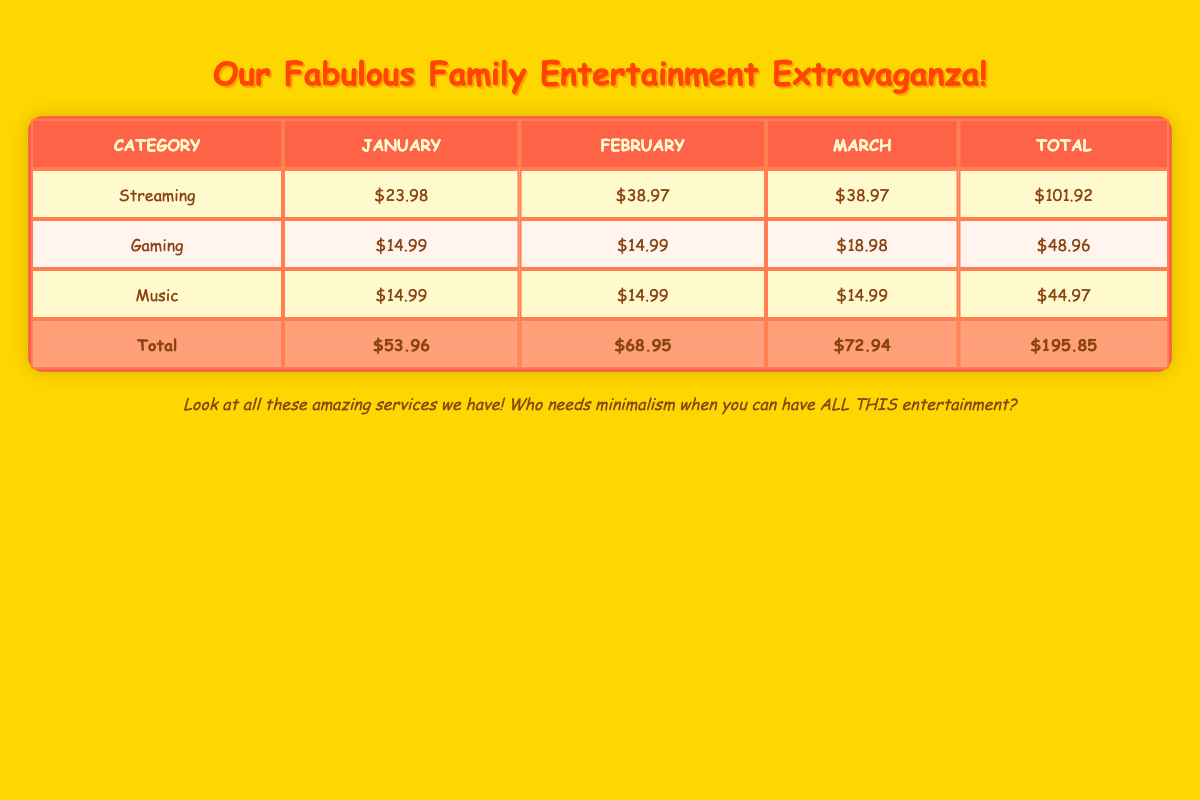What is the total cost for streaming services in January? You can find the row for "Streaming" under the January column. The total is the sum of Netflix ($15.99) and Disney+ ($7.99), which equals $15.99 + $7.99 = $23.98.
Answer: $23.98 What is the average monthly cost for music services over the three months? The total for music services is $14.99 (January) + $14.99 (February) + $14.99 (March) = $44.97. Since there are three months, the average is $44.97 / 3 = $14.99.
Answer: $14.99 Is the total cost for gaming services higher in March than in February? The total cost for gaming services is $18.98 in March (Xbox Game Pass + Nintendo Switch Online) and $14.99 in February. Since $18.98 is greater than $14.99, the statement is true.
Answer: Yes What was the increase in the total entertainment expenses from January to March? The total expenses in January are $53.96 and in March are $72.94. To find the increase, subtract January from March: $72.94 - $53.96 = $18.98.
Answer: $18.98 Which service in February had the highest cost? Looking at the February data, Netflix costs $15.99, Disney+ costs $7.99, HBO Max costs $14.99, Xbox Game Pass costs $14.99, and Spotify Family costs $14.99. The highest cost is for Netflix at $15.99.
Answer: Netflix Did the total expenses for streaming services increase, decrease, or stay the same from January to March? The total for streaming services in January is $23.98, while in March it remains $38.97. Since $38.97 is greater than $23.98, the expenses increased.
Answer: Increase What is the total cost for all entertainment services over the three months? To find the total, sum all the monthly totals across the categories: $53.96 (January) + $68.95 (February) + $72.94 (March) = $195.85. This is also the grand total displayed at the bottom of the table.
Answer: $195.85 How many different streaming services are accounted for in the table? The categories listed under streaming services over the three months include Netflix, Disney+, and HBO Max. Therefore, there are three different streaming services.
Answer: 3 What is the percentage of the total entertainment expenses that goes to music services in March? The total expenses in March are $72.94, and the total for music services is $14.99. The percentage is calculated as ($14.99 / $72.94) * 100 = approximately 20.54%.
Answer: 20.54% 